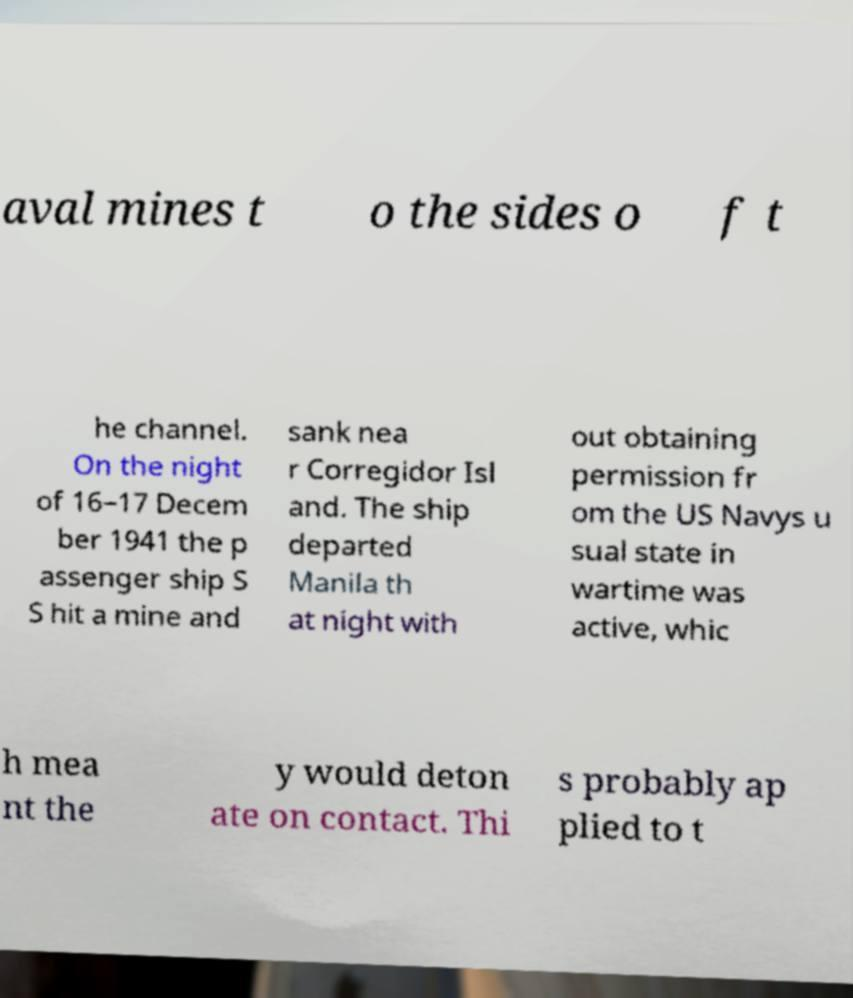Please identify and transcribe the text found in this image. aval mines t o the sides o f t he channel. On the night of 16–17 Decem ber 1941 the p assenger ship S S hit a mine and sank nea r Corregidor Isl and. The ship departed Manila th at night with out obtaining permission fr om the US Navys u sual state in wartime was active, whic h mea nt the y would deton ate on contact. Thi s probably ap plied to t 